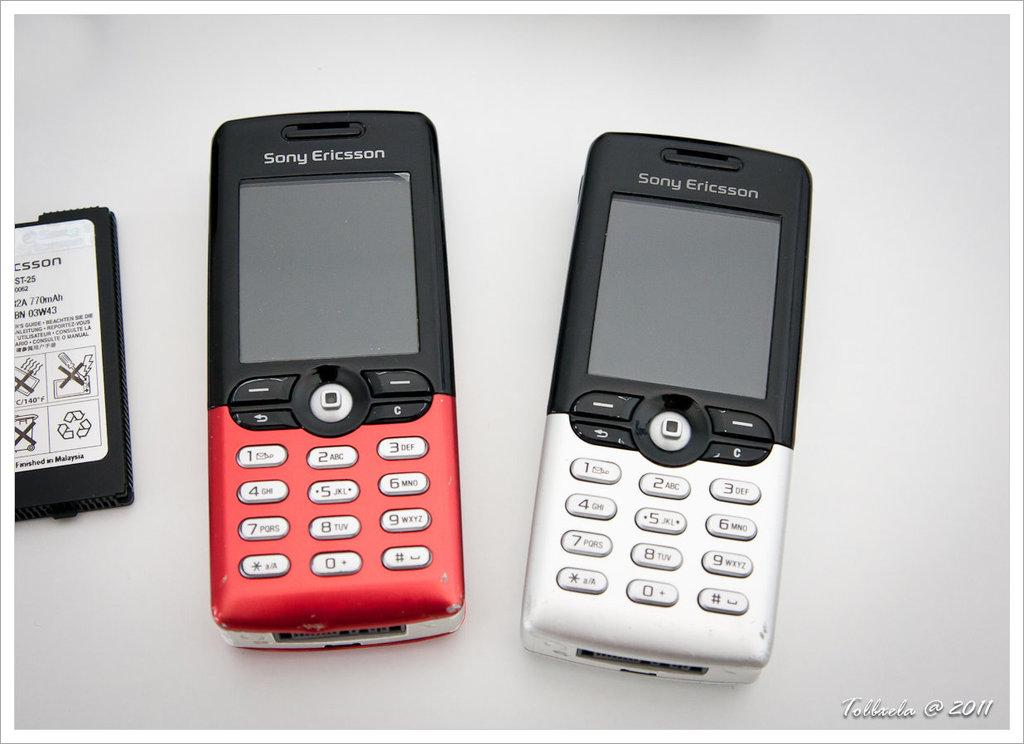<image>
Summarize the visual content of the image. A pair of old sony ericsson phones, photo taken in 2011. 